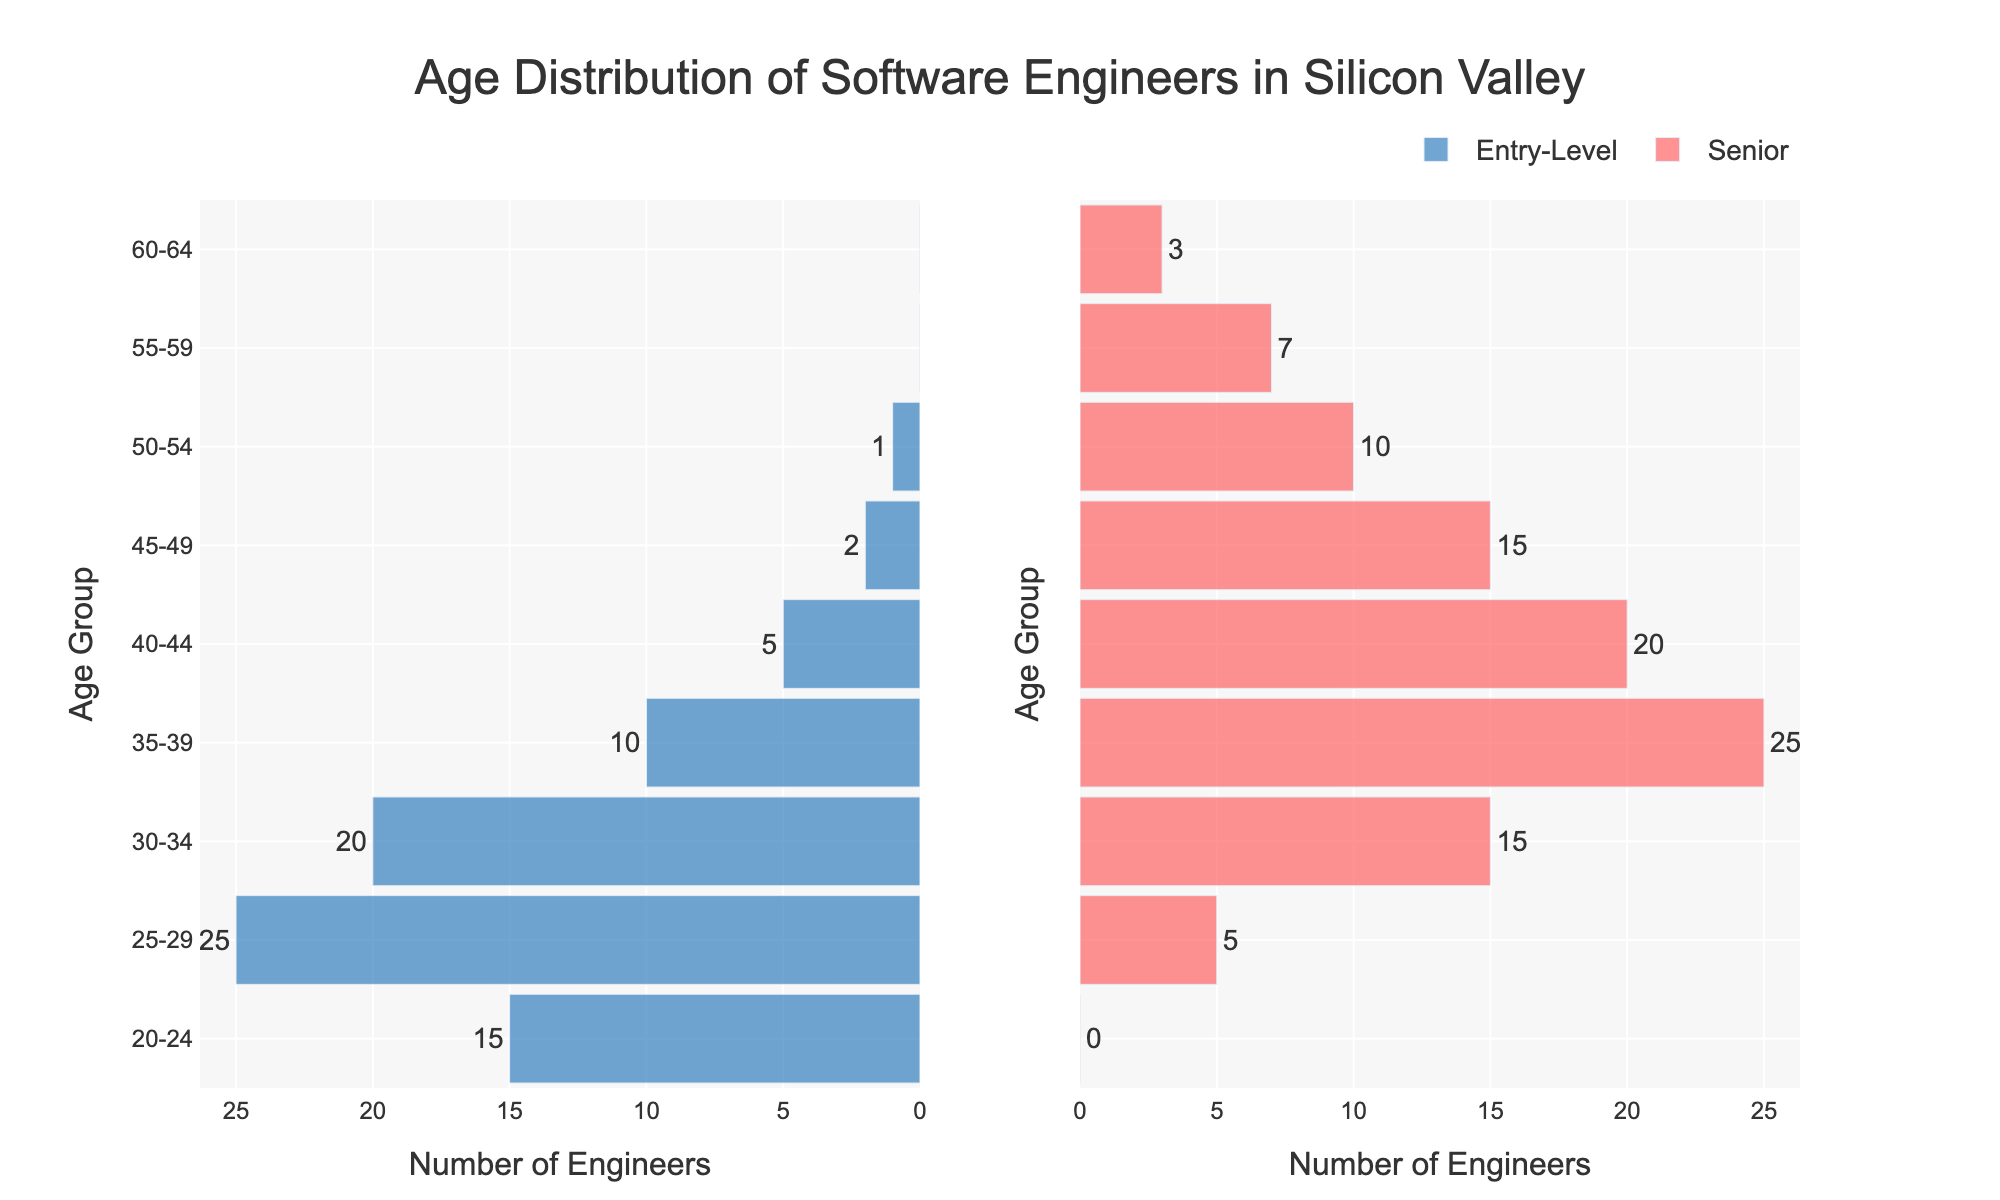What's the age group with the highest number of entry-level software engineers? The tallest bar in the entry-level section is the 25-29 age group, with a value of 25.
Answer: 25-29 Which age group has the highest number of senior positions? The tallest bar in the senior section is the 35-39 age group, with a value of 25.
Answer: 35-39 How many more entry-level engineers are there in the 25-29 age group compared to the 30-34 age group? Subtract the number of entry-level engineers in the 30-34 age group (20) from the 25-29 age group (25); thus, 25 - 20 = 5.
Answer: 5 What is the total number of senior engineers aged 40 and above? Add the number of senior engineers in the age groups 40-44 (20), 45-49 (15), 50-54 (10), 55-59 (7), and 60-64 (3); thus, 20 + 15 + 10 + 7 + 3 = 55.
Answer: 55 Is there any age group with zero entry-level engineers? If yes, which one? By examining the entry-level bars, the 55-59 and 60-64 age groups both have a value of 0.
Answer: 55-59 and 60-64 Compare the total number of entry-level engineers to the total number of senior engineers. Sum the entries for each group: entry-level (15+25+20+10+5+2+1+0+0 = 78), and seniors (0+5+15+25+20+15+10+7+3 = 100). Thus, 78 compared to 100.
Answer: 78 vs 100 What percentage of engineers, both entry-level and senior, are aged 30-34 compared to the total number of engineers? The combined number for 30-34 is 20 (entry-level) + 15 (senior) = 35. The total number of engineers is 78 (entry-level) + 100 (senior) = 178. Thus, 35/178 ≈ 19.66%.
Answer: ~19.66% 